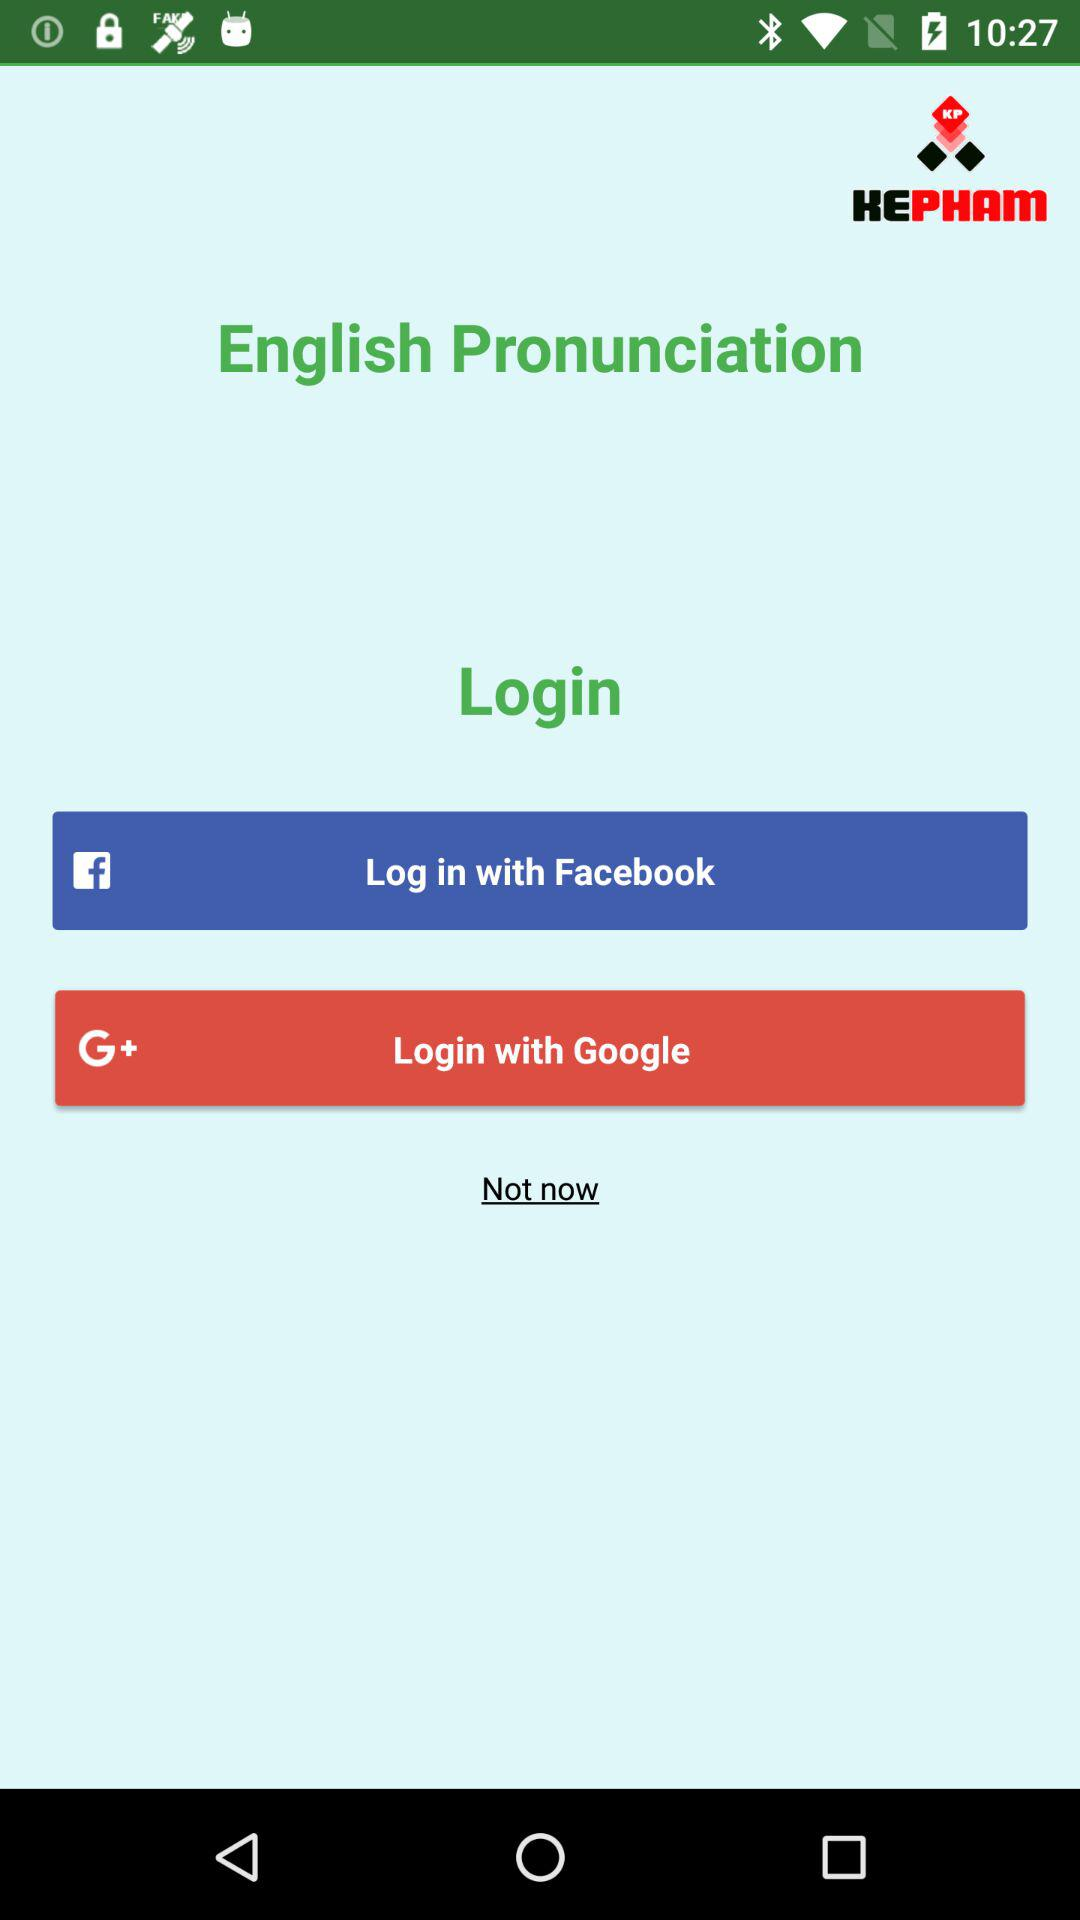Through what application can we login with? You can login with "Facebook" and "Google". 